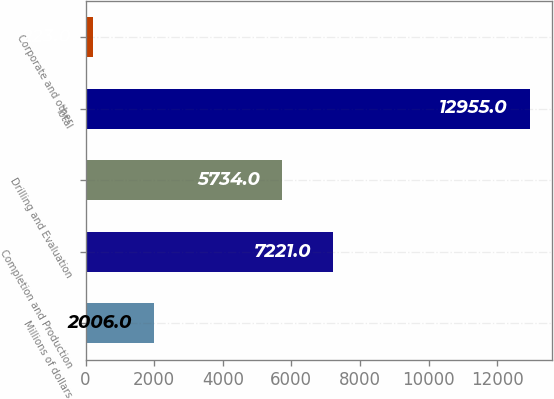Convert chart. <chart><loc_0><loc_0><loc_500><loc_500><bar_chart><fcel>Millions of dollars<fcel>Completion and Production<fcel>Drilling and Evaluation<fcel>Total<fcel>Corporate and other<nl><fcel>2006<fcel>7221<fcel>5734<fcel>12955<fcel>223<nl></chart> 